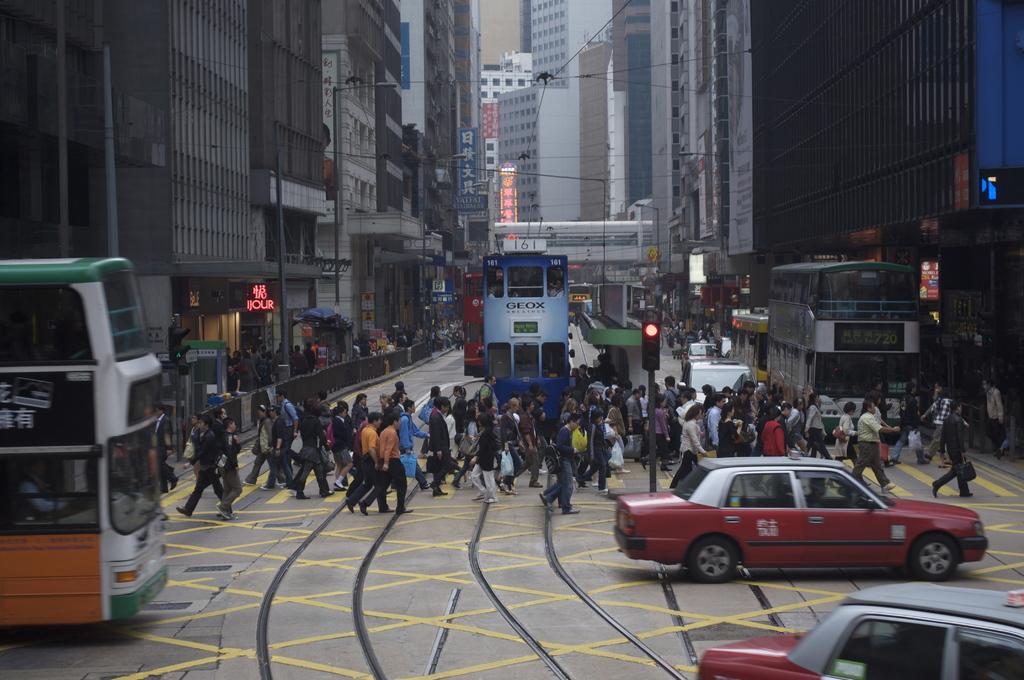What does it say on the front of the blue and white rail car?
Your answer should be very brief. Geox. What is written on the blue bus?
Ensure brevity in your answer.  Unanswerable. 